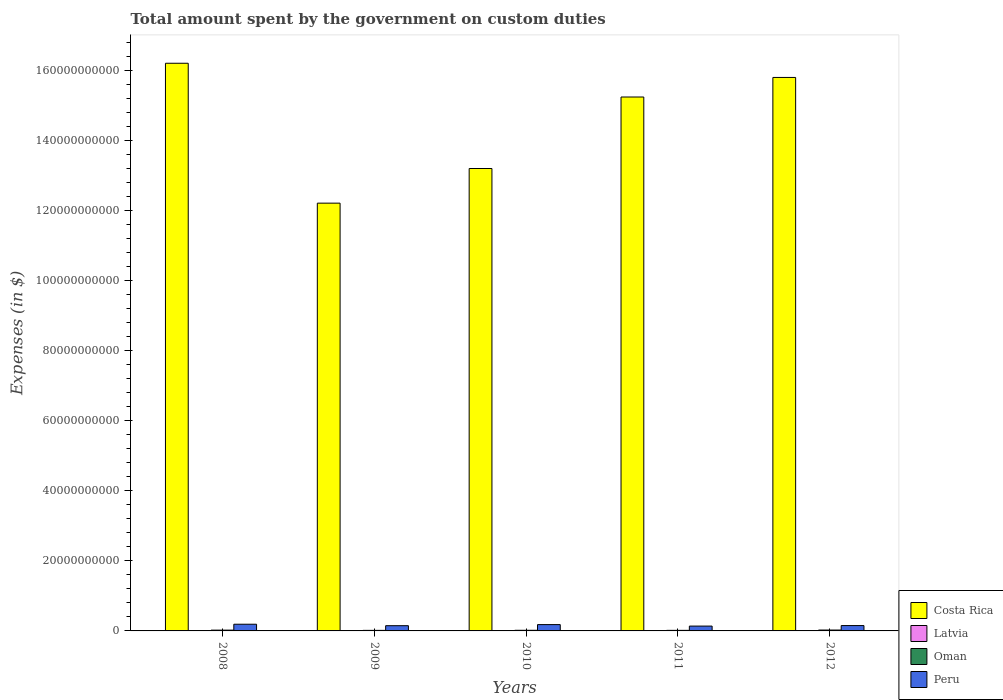How many different coloured bars are there?
Offer a very short reply. 4. How many groups of bars are there?
Provide a succinct answer. 5. How many bars are there on the 4th tick from the right?
Keep it short and to the point. 4. What is the label of the 1st group of bars from the left?
Your answer should be compact. 2008. What is the amount spent on custom duties by the government in Latvia in 2010?
Your response must be concise. 1.73e+07. Across all years, what is the maximum amount spent on custom duties by the government in Peru?
Provide a short and direct response. 1.91e+09. Across all years, what is the minimum amount spent on custom duties by the government in Costa Rica?
Provide a short and direct response. 1.22e+11. In which year was the amount spent on custom duties by the government in Peru minimum?
Your response must be concise. 2011. What is the total amount spent on custom duties by the government in Costa Rica in the graph?
Your response must be concise. 7.27e+11. What is the difference between the amount spent on custom duties by the government in Peru in 2011 and that in 2012?
Give a very brief answer. -1.46e+08. What is the difference between the amount spent on custom duties by the government in Latvia in 2008 and the amount spent on custom duties by the government in Oman in 2011?
Your response must be concise. -1.35e+08. What is the average amount spent on custom duties by the government in Peru per year?
Make the answer very short. 1.62e+09. In the year 2010, what is the difference between the amount spent on custom duties by the government in Oman and amount spent on custom duties by the government in Latvia?
Your answer should be very brief. 1.62e+08. What is the ratio of the amount spent on custom duties by the government in Latvia in 2009 to that in 2011?
Provide a short and direct response. 0.72. Is the difference between the amount spent on custom duties by the government in Oman in 2008 and 2011 greater than the difference between the amount spent on custom duties by the government in Latvia in 2008 and 2011?
Your response must be concise. Yes. What is the difference between the highest and the second highest amount spent on custom duties by the government in Costa Rica?
Give a very brief answer. 4.05e+09. What is the difference between the highest and the lowest amount spent on custom duties by the government in Peru?
Provide a short and direct response. 5.30e+08. Is the sum of the amount spent on custom duties by the government in Costa Rica in 2009 and 2011 greater than the maximum amount spent on custom duties by the government in Latvia across all years?
Give a very brief answer. Yes. What does the 2nd bar from the left in 2010 represents?
Offer a very short reply. Latvia. What does the 4th bar from the right in 2009 represents?
Offer a terse response. Costa Rica. What is the difference between two consecutive major ticks on the Y-axis?
Offer a terse response. 2.00e+1. Are the values on the major ticks of Y-axis written in scientific E-notation?
Provide a short and direct response. No. Where does the legend appear in the graph?
Ensure brevity in your answer.  Bottom right. How are the legend labels stacked?
Provide a succinct answer. Vertical. What is the title of the graph?
Offer a terse response. Total amount spent by the government on custom duties. Does "Turkmenistan" appear as one of the legend labels in the graph?
Make the answer very short. No. What is the label or title of the Y-axis?
Keep it short and to the point. Expenses (in $). What is the Expenses (in $) in Costa Rica in 2008?
Keep it short and to the point. 1.62e+11. What is the Expenses (in $) of Latvia in 2008?
Your response must be concise. 2.60e+07. What is the Expenses (in $) of Oman in 2008?
Make the answer very short. 2.27e+08. What is the Expenses (in $) of Peru in 2008?
Your answer should be compact. 1.91e+09. What is the Expenses (in $) of Costa Rica in 2009?
Ensure brevity in your answer.  1.22e+11. What is the Expenses (in $) of Latvia in 2009?
Your answer should be very brief. 1.51e+07. What is the Expenses (in $) in Oman in 2009?
Offer a terse response. 1.58e+08. What is the Expenses (in $) of Peru in 2009?
Ensure brevity in your answer.  1.49e+09. What is the Expenses (in $) of Costa Rica in 2010?
Keep it short and to the point. 1.32e+11. What is the Expenses (in $) in Latvia in 2010?
Provide a succinct answer. 1.73e+07. What is the Expenses (in $) in Oman in 2010?
Your answer should be compact. 1.80e+08. What is the Expenses (in $) in Peru in 2010?
Offer a very short reply. 1.80e+09. What is the Expenses (in $) in Costa Rica in 2011?
Offer a terse response. 1.52e+11. What is the Expenses (in $) in Latvia in 2011?
Offer a very short reply. 2.09e+07. What is the Expenses (in $) of Oman in 2011?
Your response must be concise. 1.61e+08. What is the Expenses (in $) in Peru in 2011?
Offer a very short reply. 1.38e+09. What is the Expenses (in $) of Costa Rica in 2012?
Provide a short and direct response. 1.58e+11. What is the Expenses (in $) of Latvia in 2012?
Your answer should be compact. 2.24e+07. What is the Expenses (in $) of Oman in 2012?
Ensure brevity in your answer.  2.50e+08. What is the Expenses (in $) of Peru in 2012?
Ensure brevity in your answer.  1.53e+09. Across all years, what is the maximum Expenses (in $) in Costa Rica?
Provide a short and direct response. 1.62e+11. Across all years, what is the maximum Expenses (in $) in Latvia?
Your response must be concise. 2.60e+07. Across all years, what is the maximum Expenses (in $) in Oman?
Give a very brief answer. 2.50e+08. Across all years, what is the maximum Expenses (in $) of Peru?
Provide a short and direct response. 1.91e+09. Across all years, what is the minimum Expenses (in $) in Costa Rica?
Your answer should be very brief. 1.22e+11. Across all years, what is the minimum Expenses (in $) in Latvia?
Offer a very short reply. 1.51e+07. Across all years, what is the minimum Expenses (in $) in Oman?
Give a very brief answer. 1.58e+08. Across all years, what is the minimum Expenses (in $) in Peru?
Offer a terse response. 1.38e+09. What is the total Expenses (in $) in Costa Rica in the graph?
Your answer should be compact. 7.27e+11. What is the total Expenses (in $) of Latvia in the graph?
Provide a succinct answer. 1.02e+08. What is the total Expenses (in $) in Oman in the graph?
Ensure brevity in your answer.  9.76e+08. What is the total Expenses (in $) of Peru in the graph?
Provide a short and direct response. 8.11e+09. What is the difference between the Expenses (in $) in Costa Rica in 2008 and that in 2009?
Provide a succinct answer. 3.99e+1. What is the difference between the Expenses (in $) of Latvia in 2008 and that in 2009?
Offer a terse response. 1.09e+07. What is the difference between the Expenses (in $) in Oman in 2008 and that in 2009?
Provide a short and direct response. 6.85e+07. What is the difference between the Expenses (in $) of Peru in 2008 and that in 2009?
Offer a terse response. 4.18e+08. What is the difference between the Expenses (in $) in Costa Rica in 2008 and that in 2010?
Your answer should be very brief. 3.00e+1. What is the difference between the Expenses (in $) in Latvia in 2008 and that in 2010?
Provide a succinct answer. 8.73e+06. What is the difference between the Expenses (in $) of Oman in 2008 and that in 2010?
Your answer should be very brief. 4.70e+07. What is the difference between the Expenses (in $) of Peru in 2008 and that in 2010?
Your answer should be compact. 1.08e+08. What is the difference between the Expenses (in $) of Costa Rica in 2008 and that in 2011?
Make the answer very short. 9.64e+09. What is the difference between the Expenses (in $) of Latvia in 2008 and that in 2011?
Make the answer very short. 5.13e+06. What is the difference between the Expenses (in $) in Oman in 2008 and that in 2011?
Keep it short and to the point. 6.54e+07. What is the difference between the Expenses (in $) in Peru in 2008 and that in 2011?
Keep it short and to the point. 5.30e+08. What is the difference between the Expenses (in $) in Costa Rica in 2008 and that in 2012?
Provide a succinct answer. 4.05e+09. What is the difference between the Expenses (in $) of Latvia in 2008 and that in 2012?
Offer a very short reply. 3.57e+06. What is the difference between the Expenses (in $) of Oman in 2008 and that in 2012?
Offer a very short reply. -2.35e+07. What is the difference between the Expenses (in $) in Peru in 2008 and that in 2012?
Ensure brevity in your answer.  3.85e+08. What is the difference between the Expenses (in $) of Costa Rica in 2009 and that in 2010?
Ensure brevity in your answer.  -9.89e+09. What is the difference between the Expenses (in $) in Latvia in 2009 and that in 2010?
Ensure brevity in your answer.  -2.20e+06. What is the difference between the Expenses (in $) in Oman in 2009 and that in 2010?
Your response must be concise. -2.15e+07. What is the difference between the Expenses (in $) in Peru in 2009 and that in 2010?
Offer a terse response. -3.10e+08. What is the difference between the Expenses (in $) in Costa Rica in 2009 and that in 2011?
Your answer should be compact. -3.03e+1. What is the difference between the Expenses (in $) in Latvia in 2009 and that in 2011?
Provide a succinct answer. -5.80e+06. What is the difference between the Expenses (in $) of Oman in 2009 and that in 2011?
Give a very brief answer. -3.10e+06. What is the difference between the Expenses (in $) of Peru in 2009 and that in 2011?
Ensure brevity in your answer.  1.12e+08. What is the difference between the Expenses (in $) in Costa Rica in 2009 and that in 2012?
Your answer should be compact. -3.59e+1. What is the difference between the Expenses (in $) in Latvia in 2009 and that in 2012?
Offer a very short reply. -7.36e+06. What is the difference between the Expenses (in $) of Oman in 2009 and that in 2012?
Keep it short and to the point. -9.20e+07. What is the difference between the Expenses (in $) of Peru in 2009 and that in 2012?
Your answer should be very brief. -3.32e+07. What is the difference between the Expenses (in $) in Costa Rica in 2010 and that in 2011?
Ensure brevity in your answer.  -2.04e+1. What is the difference between the Expenses (in $) in Latvia in 2010 and that in 2011?
Make the answer very short. -3.60e+06. What is the difference between the Expenses (in $) in Oman in 2010 and that in 2011?
Offer a very short reply. 1.84e+07. What is the difference between the Expenses (in $) of Peru in 2010 and that in 2011?
Provide a short and direct response. 4.23e+08. What is the difference between the Expenses (in $) of Costa Rica in 2010 and that in 2012?
Ensure brevity in your answer.  -2.60e+1. What is the difference between the Expenses (in $) in Latvia in 2010 and that in 2012?
Keep it short and to the point. -5.16e+06. What is the difference between the Expenses (in $) of Oman in 2010 and that in 2012?
Your answer should be compact. -7.05e+07. What is the difference between the Expenses (in $) of Peru in 2010 and that in 2012?
Your answer should be compact. 2.77e+08. What is the difference between the Expenses (in $) in Costa Rica in 2011 and that in 2012?
Offer a terse response. -5.59e+09. What is the difference between the Expenses (in $) of Latvia in 2011 and that in 2012?
Give a very brief answer. -1.56e+06. What is the difference between the Expenses (in $) in Oman in 2011 and that in 2012?
Provide a succinct answer. -8.89e+07. What is the difference between the Expenses (in $) in Peru in 2011 and that in 2012?
Your response must be concise. -1.46e+08. What is the difference between the Expenses (in $) in Costa Rica in 2008 and the Expenses (in $) in Latvia in 2009?
Provide a succinct answer. 1.62e+11. What is the difference between the Expenses (in $) of Costa Rica in 2008 and the Expenses (in $) of Oman in 2009?
Your response must be concise. 1.62e+11. What is the difference between the Expenses (in $) of Costa Rica in 2008 and the Expenses (in $) of Peru in 2009?
Give a very brief answer. 1.61e+11. What is the difference between the Expenses (in $) in Latvia in 2008 and the Expenses (in $) in Oman in 2009?
Provide a short and direct response. -1.32e+08. What is the difference between the Expenses (in $) of Latvia in 2008 and the Expenses (in $) of Peru in 2009?
Your answer should be compact. -1.47e+09. What is the difference between the Expenses (in $) in Oman in 2008 and the Expenses (in $) in Peru in 2009?
Your response must be concise. -1.27e+09. What is the difference between the Expenses (in $) in Costa Rica in 2008 and the Expenses (in $) in Latvia in 2010?
Your response must be concise. 1.62e+11. What is the difference between the Expenses (in $) in Costa Rica in 2008 and the Expenses (in $) in Oman in 2010?
Ensure brevity in your answer.  1.62e+11. What is the difference between the Expenses (in $) in Costa Rica in 2008 and the Expenses (in $) in Peru in 2010?
Provide a short and direct response. 1.60e+11. What is the difference between the Expenses (in $) of Latvia in 2008 and the Expenses (in $) of Oman in 2010?
Make the answer very short. -1.54e+08. What is the difference between the Expenses (in $) in Latvia in 2008 and the Expenses (in $) in Peru in 2010?
Your response must be concise. -1.78e+09. What is the difference between the Expenses (in $) in Oman in 2008 and the Expenses (in $) in Peru in 2010?
Provide a short and direct response. -1.58e+09. What is the difference between the Expenses (in $) in Costa Rica in 2008 and the Expenses (in $) in Latvia in 2011?
Keep it short and to the point. 1.62e+11. What is the difference between the Expenses (in $) in Costa Rica in 2008 and the Expenses (in $) in Oman in 2011?
Make the answer very short. 1.62e+11. What is the difference between the Expenses (in $) in Costa Rica in 2008 and the Expenses (in $) in Peru in 2011?
Offer a terse response. 1.61e+11. What is the difference between the Expenses (in $) of Latvia in 2008 and the Expenses (in $) of Oman in 2011?
Keep it short and to the point. -1.35e+08. What is the difference between the Expenses (in $) in Latvia in 2008 and the Expenses (in $) in Peru in 2011?
Provide a short and direct response. -1.35e+09. What is the difference between the Expenses (in $) of Oman in 2008 and the Expenses (in $) of Peru in 2011?
Provide a succinct answer. -1.15e+09. What is the difference between the Expenses (in $) of Costa Rica in 2008 and the Expenses (in $) of Latvia in 2012?
Offer a very short reply. 1.62e+11. What is the difference between the Expenses (in $) in Costa Rica in 2008 and the Expenses (in $) in Oman in 2012?
Your answer should be compact. 1.62e+11. What is the difference between the Expenses (in $) in Costa Rica in 2008 and the Expenses (in $) in Peru in 2012?
Your answer should be very brief. 1.61e+11. What is the difference between the Expenses (in $) of Latvia in 2008 and the Expenses (in $) of Oman in 2012?
Keep it short and to the point. -2.24e+08. What is the difference between the Expenses (in $) of Latvia in 2008 and the Expenses (in $) of Peru in 2012?
Your answer should be compact. -1.50e+09. What is the difference between the Expenses (in $) of Oman in 2008 and the Expenses (in $) of Peru in 2012?
Give a very brief answer. -1.30e+09. What is the difference between the Expenses (in $) in Costa Rica in 2009 and the Expenses (in $) in Latvia in 2010?
Make the answer very short. 1.22e+11. What is the difference between the Expenses (in $) of Costa Rica in 2009 and the Expenses (in $) of Oman in 2010?
Your answer should be compact. 1.22e+11. What is the difference between the Expenses (in $) of Costa Rica in 2009 and the Expenses (in $) of Peru in 2010?
Ensure brevity in your answer.  1.20e+11. What is the difference between the Expenses (in $) in Latvia in 2009 and the Expenses (in $) in Oman in 2010?
Make the answer very short. -1.65e+08. What is the difference between the Expenses (in $) of Latvia in 2009 and the Expenses (in $) of Peru in 2010?
Your answer should be very brief. -1.79e+09. What is the difference between the Expenses (in $) in Oman in 2009 and the Expenses (in $) in Peru in 2010?
Offer a very short reply. -1.64e+09. What is the difference between the Expenses (in $) in Costa Rica in 2009 and the Expenses (in $) in Latvia in 2011?
Make the answer very short. 1.22e+11. What is the difference between the Expenses (in $) in Costa Rica in 2009 and the Expenses (in $) in Oman in 2011?
Your response must be concise. 1.22e+11. What is the difference between the Expenses (in $) in Costa Rica in 2009 and the Expenses (in $) in Peru in 2011?
Your answer should be very brief. 1.21e+11. What is the difference between the Expenses (in $) of Latvia in 2009 and the Expenses (in $) of Oman in 2011?
Offer a terse response. -1.46e+08. What is the difference between the Expenses (in $) of Latvia in 2009 and the Expenses (in $) of Peru in 2011?
Offer a very short reply. -1.37e+09. What is the difference between the Expenses (in $) in Oman in 2009 and the Expenses (in $) in Peru in 2011?
Provide a short and direct response. -1.22e+09. What is the difference between the Expenses (in $) of Costa Rica in 2009 and the Expenses (in $) of Latvia in 2012?
Your answer should be compact. 1.22e+11. What is the difference between the Expenses (in $) in Costa Rica in 2009 and the Expenses (in $) in Oman in 2012?
Give a very brief answer. 1.22e+11. What is the difference between the Expenses (in $) of Costa Rica in 2009 and the Expenses (in $) of Peru in 2012?
Ensure brevity in your answer.  1.21e+11. What is the difference between the Expenses (in $) of Latvia in 2009 and the Expenses (in $) of Oman in 2012?
Make the answer very short. -2.35e+08. What is the difference between the Expenses (in $) in Latvia in 2009 and the Expenses (in $) in Peru in 2012?
Offer a terse response. -1.51e+09. What is the difference between the Expenses (in $) of Oman in 2009 and the Expenses (in $) of Peru in 2012?
Offer a terse response. -1.37e+09. What is the difference between the Expenses (in $) of Costa Rica in 2010 and the Expenses (in $) of Latvia in 2011?
Your response must be concise. 1.32e+11. What is the difference between the Expenses (in $) in Costa Rica in 2010 and the Expenses (in $) in Oman in 2011?
Your response must be concise. 1.32e+11. What is the difference between the Expenses (in $) in Costa Rica in 2010 and the Expenses (in $) in Peru in 2011?
Your answer should be very brief. 1.31e+11. What is the difference between the Expenses (in $) of Latvia in 2010 and the Expenses (in $) of Oman in 2011?
Make the answer very short. -1.44e+08. What is the difference between the Expenses (in $) of Latvia in 2010 and the Expenses (in $) of Peru in 2011?
Your answer should be very brief. -1.36e+09. What is the difference between the Expenses (in $) in Oman in 2010 and the Expenses (in $) in Peru in 2011?
Your answer should be very brief. -1.20e+09. What is the difference between the Expenses (in $) in Costa Rica in 2010 and the Expenses (in $) in Latvia in 2012?
Provide a short and direct response. 1.32e+11. What is the difference between the Expenses (in $) in Costa Rica in 2010 and the Expenses (in $) in Oman in 2012?
Offer a very short reply. 1.32e+11. What is the difference between the Expenses (in $) of Costa Rica in 2010 and the Expenses (in $) of Peru in 2012?
Provide a succinct answer. 1.30e+11. What is the difference between the Expenses (in $) of Latvia in 2010 and the Expenses (in $) of Oman in 2012?
Ensure brevity in your answer.  -2.33e+08. What is the difference between the Expenses (in $) of Latvia in 2010 and the Expenses (in $) of Peru in 2012?
Provide a short and direct response. -1.51e+09. What is the difference between the Expenses (in $) in Oman in 2010 and the Expenses (in $) in Peru in 2012?
Provide a succinct answer. -1.35e+09. What is the difference between the Expenses (in $) of Costa Rica in 2011 and the Expenses (in $) of Latvia in 2012?
Give a very brief answer. 1.52e+11. What is the difference between the Expenses (in $) in Costa Rica in 2011 and the Expenses (in $) in Oman in 2012?
Make the answer very short. 1.52e+11. What is the difference between the Expenses (in $) in Costa Rica in 2011 and the Expenses (in $) in Peru in 2012?
Your answer should be compact. 1.51e+11. What is the difference between the Expenses (in $) of Latvia in 2011 and the Expenses (in $) of Oman in 2012?
Provide a succinct answer. -2.29e+08. What is the difference between the Expenses (in $) of Latvia in 2011 and the Expenses (in $) of Peru in 2012?
Make the answer very short. -1.51e+09. What is the difference between the Expenses (in $) in Oman in 2011 and the Expenses (in $) in Peru in 2012?
Offer a very short reply. -1.36e+09. What is the average Expenses (in $) of Costa Rica per year?
Your answer should be very brief. 1.45e+11. What is the average Expenses (in $) of Latvia per year?
Ensure brevity in your answer.  2.03e+07. What is the average Expenses (in $) in Oman per year?
Make the answer very short. 1.95e+08. What is the average Expenses (in $) in Peru per year?
Your answer should be compact. 1.62e+09. In the year 2008, what is the difference between the Expenses (in $) of Costa Rica and Expenses (in $) of Latvia?
Give a very brief answer. 1.62e+11. In the year 2008, what is the difference between the Expenses (in $) of Costa Rica and Expenses (in $) of Oman?
Offer a terse response. 1.62e+11. In the year 2008, what is the difference between the Expenses (in $) in Costa Rica and Expenses (in $) in Peru?
Make the answer very short. 1.60e+11. In the year 2008, what is the difference between the Expenses (in $) of Latvia and Expenses (in $) of Oman?
Keep it short and to the point. -2.01e+08. In the year 2008, what is the difference between the Expenses (in $) of Latvia and Expenses (in $) of Peru?
Ensure brevity in your answer.  -1.88e+09. In the year 2008, what is the difference between the Expenses (in $) in Oman and Expenses (in $) in Peru?
Give a very brief answer. -1.68e+09. In the year 2009, what is the difference between the Expenses (in $) of Costa Rica and Expenses (in $) of Latvia?
Offer a very short reply. 1.22e+11. In the year 2009, what is the difference between the Expenses (in $) in Costa Rica and Expenses (in $) in Oman?
Offer a very short reply. 1.22e+11. In the year 2009, what is the difference between the Expenses (in $) of Costa Rica and Expenses (in $) of Peru?
Make the answer very short. 1.21e+11. In the year 2009, what is the difference between the Expenses (in $) of Latvia and Expenses (in $) of Oman?
Your response must be concise. -1.43e+08. In the year 2009, what is the difference between the Expenses (in $) in Latvia and Expenses (in $) in Peru?
Offer a very short reply. -1.48e+09. In the year 2009, what is the difference between the Expenses (in $) of Oman and Expenses (in $) of Peru?
Provide a short and direct response. -1.33e+09. In the year 2010, what is the difference between the Expenses (in $) of Costa Rica and Expenses (in $) of Latvia?
Give a very brief answer. 1.32e+11. In the year 2010, what is the difference between the Expenses (in $) in Costa Rica and Expenses (in $) in Oman?
Your response must be concise. 1.32e+11. In the year 2010, what is the difference between the Expenses (in $) of Costa Rica and Expenses (in $) of Peru?
Provide a short and direct response. 1.30e+11. In the year 2010, what is the difference between the Expenses (in $) in Latvia and Expenses (in $) in Oman?
Your answer should be very brief. -1.62e+08. In the year 2010, what is the difference between the Expenses (in $) in Latvia and Expenses (in $) in Peru?
Offer a very short reply. -1.79e+09. In the year 2010, what is the difference between the Expenses (in $) of Oman and Expenses (in $) of Peru?
Keep it short and to the point. -1.62e+09. In the year 2011, what is the difference between the Expenses (in $) of Costa Rica and Expenses (in $) of Latvia?
Offer a very short reply. 1.52e+11. In the year 2011, what is the difference between the Expenses (in $) in Costa Rica and Expenses (in $) in Oman?
Ensure brevity in your answer.  1.52e+11. In the year 2011, what is the difference between the Expenses (in $) in Costa Rica and Expenses (in $) in Peru?
Your answer should be very brief. 1.51e+11. In the year 2011, what is the difference between the Expenses (in $) of Latvia and Expenses (in $) of Oman?
Give a very brief answer. -1.40e+08. In the year 2011, what is the difference between the Expenses (in $) of Latvia and Expenses (in $) of Peru?
Ensure brevity in your answer.  -1.36e+09. In the year 2011, what is the difference between the Expenses (in $) of Oman and Expenses (in $) of Peru?
Offer a very short reply. -1.22e+09. In the year 2012, what is the difference between the Expenses (in $) in Costa Rica and Expenses (in $) in Latvia?
Your answer should be compact. 1.58e+11. In the year 2012, what is the difference between the Expenses (in $) of Costa Rica and Expenses (in $) of Oman?
Provide a short and direct response. 1.58e+11. In the year 2012, what is the difference between the Expenses (in $) in Costa Rica and Expenses (in $) in Peru?
Your answer should be compact. 1.56e+11. In the year 2012, what is the difference between the Expenses (in $) of Latvia and Expenses (in $) of Oman?
Offer a terse response. -2.28e+08. In the year 2012, what is the difference between the Expenses (in $) of Latvia and Expenses (in $) of Peru?
Provide a short and direct response. -1.50e+09. In the year 2012, what is the difference between the Expenses (in $) in Oman and Expenses (in $) in Peru?
Give a very brief answer. -1.28e+09. What is the ratio of the Expenses (in $) in Costa Rica in 2008 to that in 2009?
Your response must be concise. 1.33. What is the ratio of the Expenses (in $) in Latvia in 2008 to that in 2009?
Your response must be concise. 1.73. What is the ratio of the Expenses (in $) of Oman in 2008 to that in 2009?
Keep it short and to the point. 1.43. What is the ratio of the Expenses (in $) in Peru in 2008 to that in 2009?
Your answer should be compact. 1.28. What is the ratio of the Expenses (in $) of Costa Rica in 2008 to that in 2010?
Give a very brief answer. 1.23. What is the ratio of the Expenses (in $) in Latvia in 2008 to that in 2010?
Your answer should be compact. 1.51. What is the ratio of the Expenses (in $) in Oman in 2008 to that in 2010?
Offer a very short reply. 1.26. What is the ratio of the Expenses (in $) of Peru in 2008 to that in 2010?
Your response must be concise. 1.06. What is the ratio of the Expenses (in $) in Costa Rica in 2008 to that in 2011?
Your answer should be very brief. 1.06. What is the ratio of the Expenses (in $) in Latvia in 2008 to that in 2011?
Offer a terse response. 1.25. What is the ratio of the Expenses (in $) in Oman in 2008 to that in 2011?
Keep it short and to the point. 1.41. What is the ratio of the Expenses (in $) of Peru in 2008 to that in 2011?
Offer a terse response. 1.38. What is the ratio of the Expenses (in $) of Costa Rica in 2008 to that in 2012?
Offer a terse response. 1.03. What is the ratio of the Expenses (in $) of Latvia in 2008 to that in 2012?
Make the answer very short. 1.16. What is the ratio of the Expenses (in $) of Oman in 2008 to that in 2012?
Your answer should be compact. 0.91. What is the ratio of the Expenses (in $) of Peru in 2008 to that in 2012?
Make the answer very short. 1.25. What is the ratio of the Expenses (in $) of Costa Rica in 2009 to that in 2010?
Make the answer very short. 0.93. What is the ratio of the Expenses (in $) in Latvia in 2009 to that in 2010?
Keep it short and to the point. 0.87. What is the ratio of the Expenses (in $) of Oman in 2009 to that in 2010?
Offer a very short reply. 0.88. What is the ratio of the Expenses (in $) of Peru in 2009 to that in 2010?
Offer a terse response. 0.83. What is the ratio of the Expenses (in $) of Costa Rica in 2009 to that in 2011?
Ensure brevity in your answer.  0.8. What is the ratio of the Expenses (in $) in Latvia in 2009 to that in 2011?
Offer a terse response. 0.72. What is the ratio of the Expenses (in $) of Oman in 2009 to that in 2011?
Offer a very short reply. 0.98. What is the ratio of the Expenses (in $) of Peru in 2009 to that in 2011?
Give a very brief answer. 1.08. What is the ratio of the Expenses (in $) in Costa Rica in 2009 to that in 2012?
Your answer should be compact. 0.77. What is the ratio of the Expenses (in $) of Latvia in 2009 to that in 2012?
Your answer should be compact. 0.67. What is the ratio of the Expenses (in $) of Oman in 2009 to that in 2012?
Provide a succinct answer. 0.63. What is the ratio of the Expenses (in $) of Peru in 2009 to that in 2012?
Give a very brief answer. 0.98. What is the ratio of the Expenses (in $) in Costa Rica in 2010 to that in 2011?
Your response must be concise. 0.87. What is the ratio of the Expenses (in $) in Latvia in 2010 to that in 2011?
Provide a succinct answer. 0.83. What is the ratio of the Expenses (in $) in Oman in 2010 to that in 2011?
Keep it short and to the point. 1.11. What is the ratio of the Expenses (in $) in Peru in 2010 to that in 2011?
Make the answer very short. 1.31. What is the ratio of the Expenses (in $) of Costa Rica in 2010 to that in 2012?
Give a very brief answer. 0.84. What is the ratio of the Expenses (in $) in Latvia in 2010 to that in 2012?
Make the answer very short. 0.77. What is the ratio of the Expenses (in $) of Oman in 2010 to that in 2012?
Offer a very short reply. 0.72. What is the ratio of the Expenses (in $) of Peru in 2010 to that in 2012?
Provide a short and direct response. 1.18. What is the ratio of the Expenses (in $) of Costa Rica in 2011 to that in 2012?
Give a very brief answer. 0.96. What is the ratio of the Expenses (in $) in Latvia in 2011 to that in 2012?
Offer a terse response. 0.93. What is the ratio of the Expenses (in $) of Oman in 2011 to that in 2012?
Ensure brevity in your answer.  0.64. What is the ratio of the Expenses (in $) of Peru in 2011 to that in 2012?
Make the answer very short. 0.9. What is the difference between the highest and the second highest Expenses (in $) in Costa Rica?
Give a very brief answer. 4.05e+09. What is the difference between the highest and the second highest Expenses (in $) of Latvia?
Ensure brevity in your answer.  3.57e+06. What is the difference between the highest and the second highest Expenses (in $) in Oman?
Make the answer very short. 2.35e+07. What is the difference between the highest and the second highest Expenses (in $) of Peru?
Your answer should be very brief. 1.08e+08. What is the difference between the highest and the lowest Expenses (in $) in Costa Rica?
Offer a terse response. 3.99e+1. What is the difference between the highest and the lowest Expenses (in $) of Latvia?
Ensure brevity in your answer.  1.09e+07. What is the difference between the highest and the lowest Expenses (in $) of Oman?
Your answer should be compact. 9.20e+07. What is the difference between the highest and the lowest Expenses (in $) of Peru?
Give a very brief answer. 5.30e+08. 